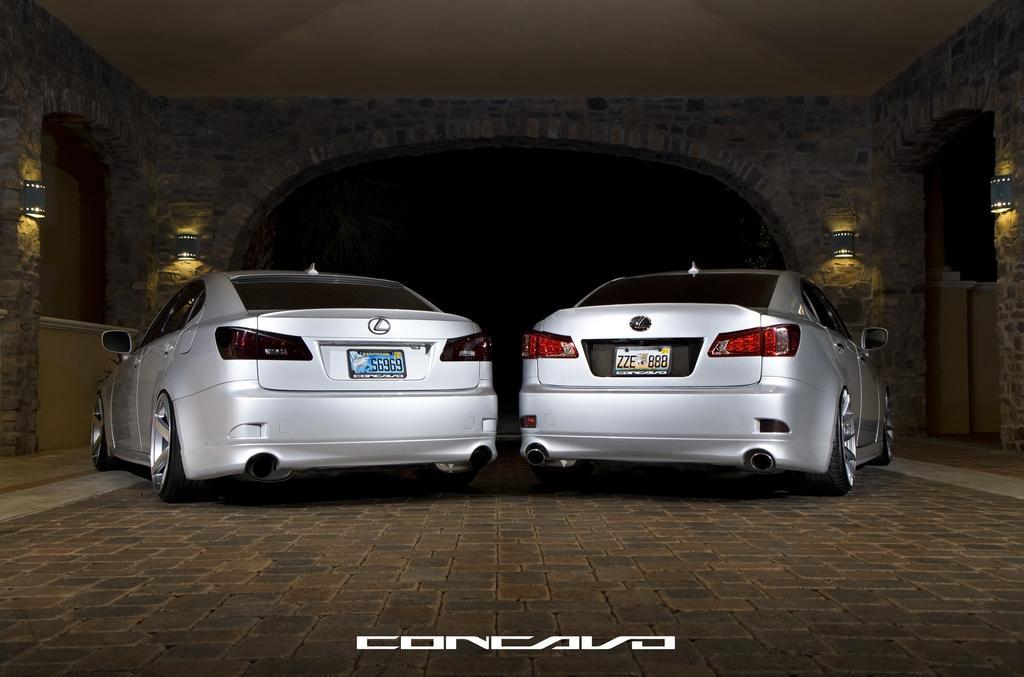Describe this image in one or two sentences. In the center of the image we can see cars. In the background there is an arch and we can see lights placed on the wall. 